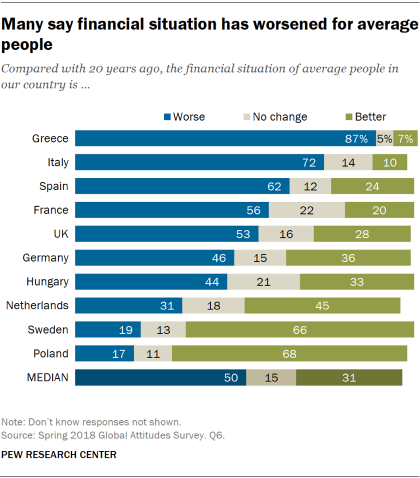Indicate a few pertinent items in this graphic. The largest bar in Greece is blue. The ratio of the median of the blue bar to the median of the gray bar is 0.41875. 